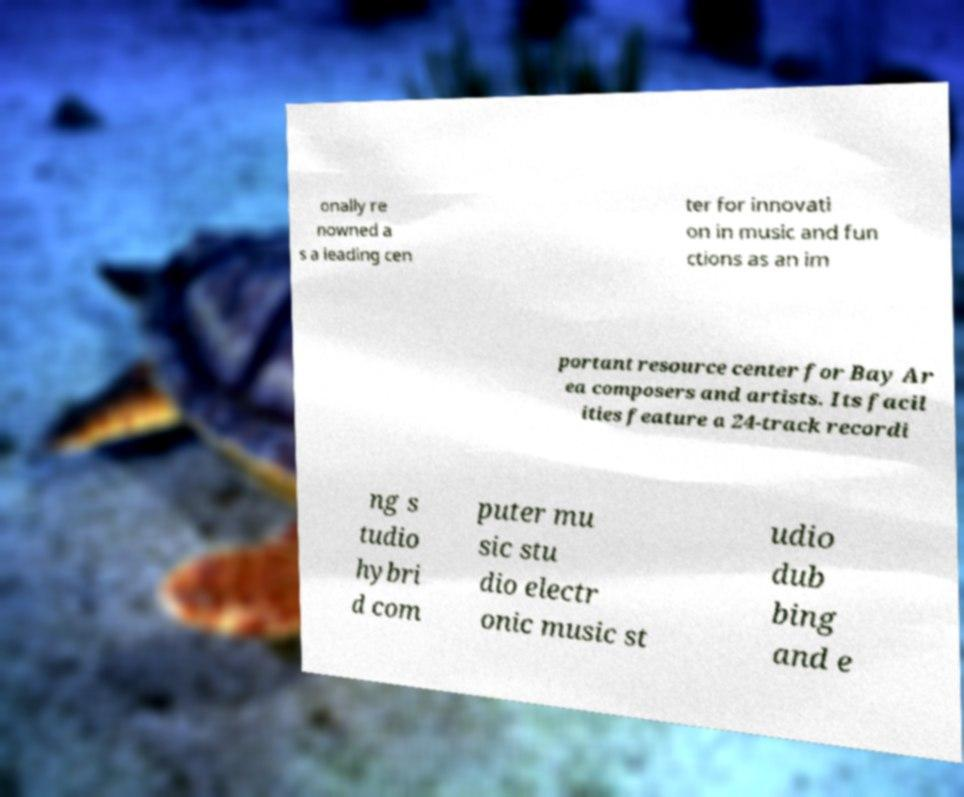Can you accurately transcribe the text from the provided image for me? onally re nowned a s a leading cen ter for innovati on in music and fun ctions as an im portant resource center for Bay Ar ea composers and artists. Its facil ities feature a 24-track recordi ng s tudio hybri d com puter mu sic stu dio electr onic music st udio dub bing and e 